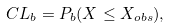<formula> <loc_0><loc_0><loc_500><loc_500>C L _ { b } = P _ { b } ( X \leq X _ { o b s } ) ,</formula> 